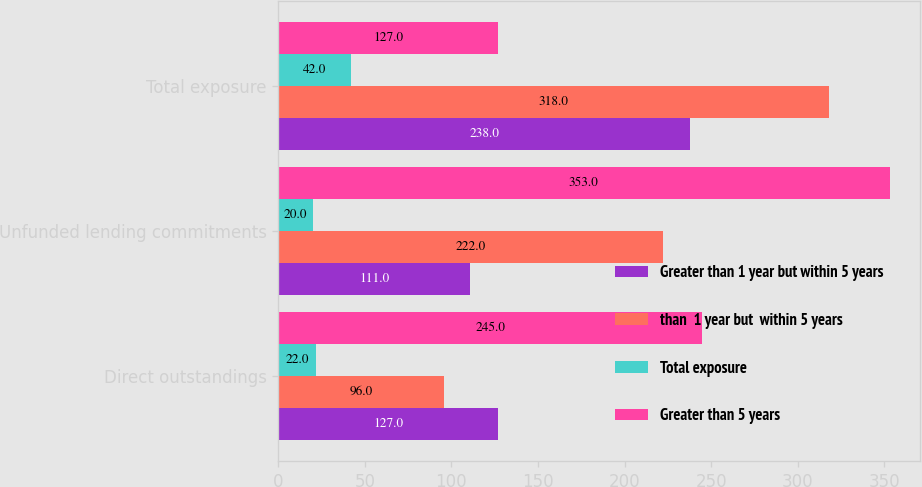Convert chart. <chart><loc_0><loc_0><loc_500><loc_500><stacked_bar_chart><ecel><fcel>Direct outstandings<fcel>Unfunded lending commitments<fcel>Total exposure<nl><fcel>Greater than 1 year but within 5 years<fcel>127<fcel>111<fcel>238<nl><fcel>than  1 year but  within 5 years<fcel>96<fcel>222<fcel>318<nl><fcel>Total exposure<fcel>22<fcel>20<fcel>42<nl><fcel>Greater than 5 years<fcel>245<fcel>353<fcel>127<nl></chart> 